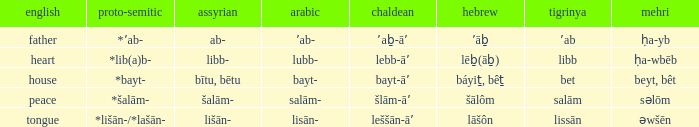If the aramaic is šlām-āʼ, what is the english? Peace. Could you help me parse every detail presented in this table? {'header': ['english', 'proto-semitic', 'assyrian', 'arabic', 'chaldean', 'hebrew', 'tigrinya', 'mehri'], 'rows': [['father', '*ʼab-', 'ab-', 'ʼab-', 'ʼaḇ-āʼ', 'ʼāḇ', 'ʼab', 'ḥa-yb'], ['heart', '*lib(a)b-', 'libb-', 'lubb-', 'lebb-āʼ', 'lēḇ(āḇ)', 'libb', 'ḥa-wbēb'], ['house', '*bayt-', 'bītu, bētu', 'bayt-', 'bayt-āʼ', 'báyiṯ, bêṯ', 'bet', 'beyt, bêt'], ['peace', '*šalām-', 'šalām-', 'salām-', 'šlām-āʼ', 'šālôm', 'salām', 'səlōm'], ['tongue', '*lišān-/*lašān-', 'lišān-', 'lisān-', 'leššān-āʼ', 'lāšôn', 'lissān', 'əwšēn']]} 